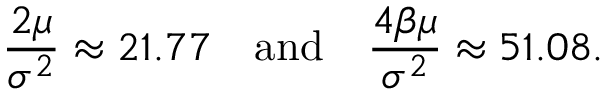Convert formula to latex. <formula><loc_0><loc_0><loc_500><loc_500>\frac { 2 \mu } { \sigma ^ { 2 } } \approx 2 1 . 7 7 \quad a n d \quad \frac { 4 \beta \mu } { \sigma ^ { 2 } } \approx 5 1 . 0 8 .</formula> 